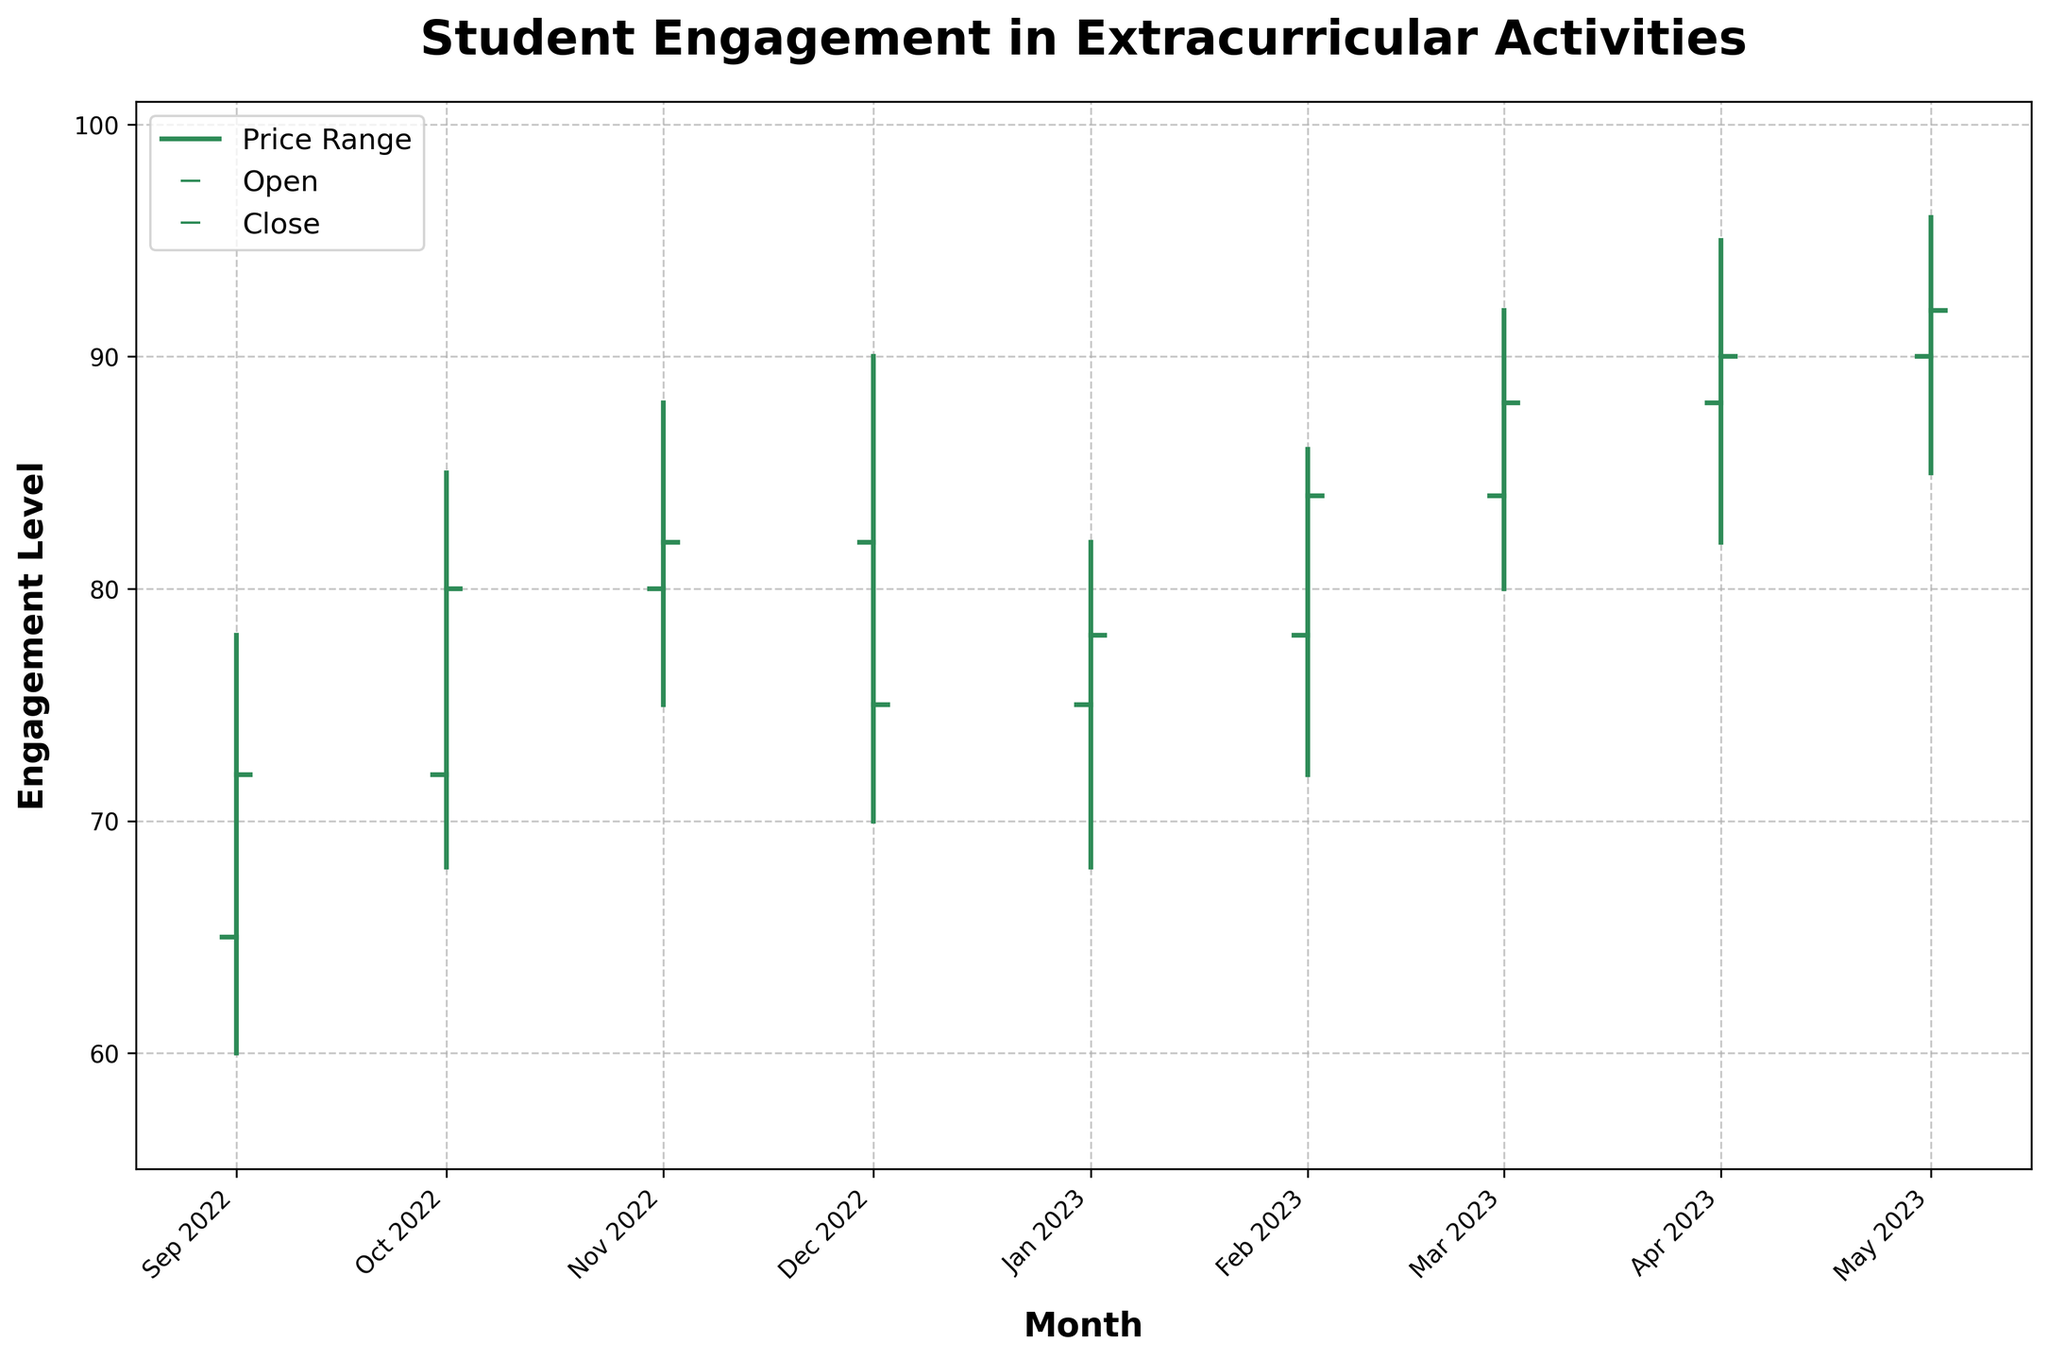What is the title of the figure? The title is usually displayed at the top of the figure and summarizes the main topic of the plot. In this case, it is "Student Engagement in Extracurricular Activities".
Answer: "Student Engagement in Extracurricular Activities" Which month recorded the highest engagement level at any point during the academic year? To find the highest engagement level, look for the month with the highest "High" value. April 2023 has the highest value of 95.
Answer: April 2023 What are the engagement level ranges (High-Low) in Sep 2022 and Apr 2023? For Sep 2022, the range is calculated as High (78) - Low (60), which equals 18. For Apr 2023, the range is High (95) - Low (82), which equals 13.
Answer: Sep 2022: 18, Apr 2023: 13 Which month had the lowest closing engagement level? The closing engagement level is found on the Close data. December 2022 had the lowest Close value of 75.
Answer: December 2022 How does the engagement level in Feb 2023 compare to that in Jan 2023? Compare the Close values. Feb 2023 closed at 84 and Jan 2023 closed at 78. Hence, the engagement level in Feb was higher than in Jan.
Answer: Higher What is the average closing engagement level from Sep 2022 to May 2023? To find the average, add up all the Close values and divide by the number of months: (72 + 80 + 82 + 75 + 78 + 84 + 88 + 90 + 92) / 9 = 82.33, rounded to 2 decimal places.
Answer: 82.33 Which month showed the largest drop in engagement from its highest to lowest level? Look for the maximum difference between High and Low in any month. Dec 2022 had the highest drop, with High (90) - Low (70), equaling 20.
Answer: December 2022 How did the engagement level trend from Sep 2022 to Nov 2022? Observe the closing engagement levels over these months. They show an increasing trend: 72 (Sep), 80 (Oct), 82 (Nov).
Answer: Increasing trend Which month showed the smallest inter-monthly fluctuation in engagement? The smallest fluctuation is indicated by the smallest range (High - Low). Nov 2022 had the smallest range: 88 - 75 = 13.
Answer: November 2022 